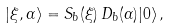Convert formula to latex. <formula><loc_0><loc_0><loc_500><loc_500>| \xi , \alpha \rangle & = S _ { b } ( \xi ) \, D _ { b } ( \alpha ) | 0 \rangle \, ,</formula> 